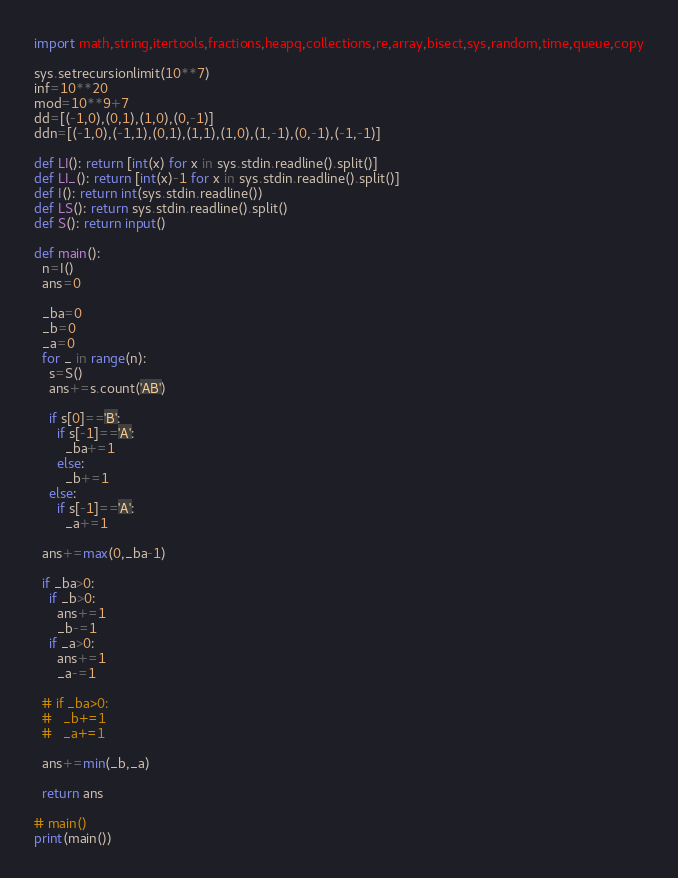<code> <loc_0><loc_0><loc_500><loc_500><_Python_>import math,string,itertools,fractions,heapq,collections,re,array,bisect,sys,random,time,queue,copy

sys.setrecursionlimit(10**7)
inf=10**20
mod=10**9+7
dd=[(-1,0),(0,1),(1,0),(0,-1)]
ddn=[(-1,0),(-1,1),(0,1),(1,1),(1,0),(1,-1),(0,-1),(-1,-1)]

def LI(): return [int(x) for x in sys.stdin.readline().split()]
def LI_(): return [int(x)-1 for x in sys.stdin.readline().split()]
def I(): return int(sys.stdin.readline())
def LS(): return sys.stdin.readline().split()
def S(): return input()

def main():
  n=I()
  ans=0

  _ba=0
  _b=0
  _a=0
  for _ in range(n):
    s=S()
    ans+=s.count('AB')

    if s[0]=='B':
      if s[-1]=='A':
        _ba+=1
      else:
        _b+=1
    else:
      if s[-1]=='A':
        _a+=1

  ans+=max(0,_ba-1)

  if _ba>0:
    if _b>0:
      ans+=1
      _b-=1
    if _a>0:
      ans+=1
      _a-=1

  # if _ba>0:
  #   _b+=1
  #   _a+=1

  ans+=min(_b,_a)

  return ans

# main()
print(main())
</code> 